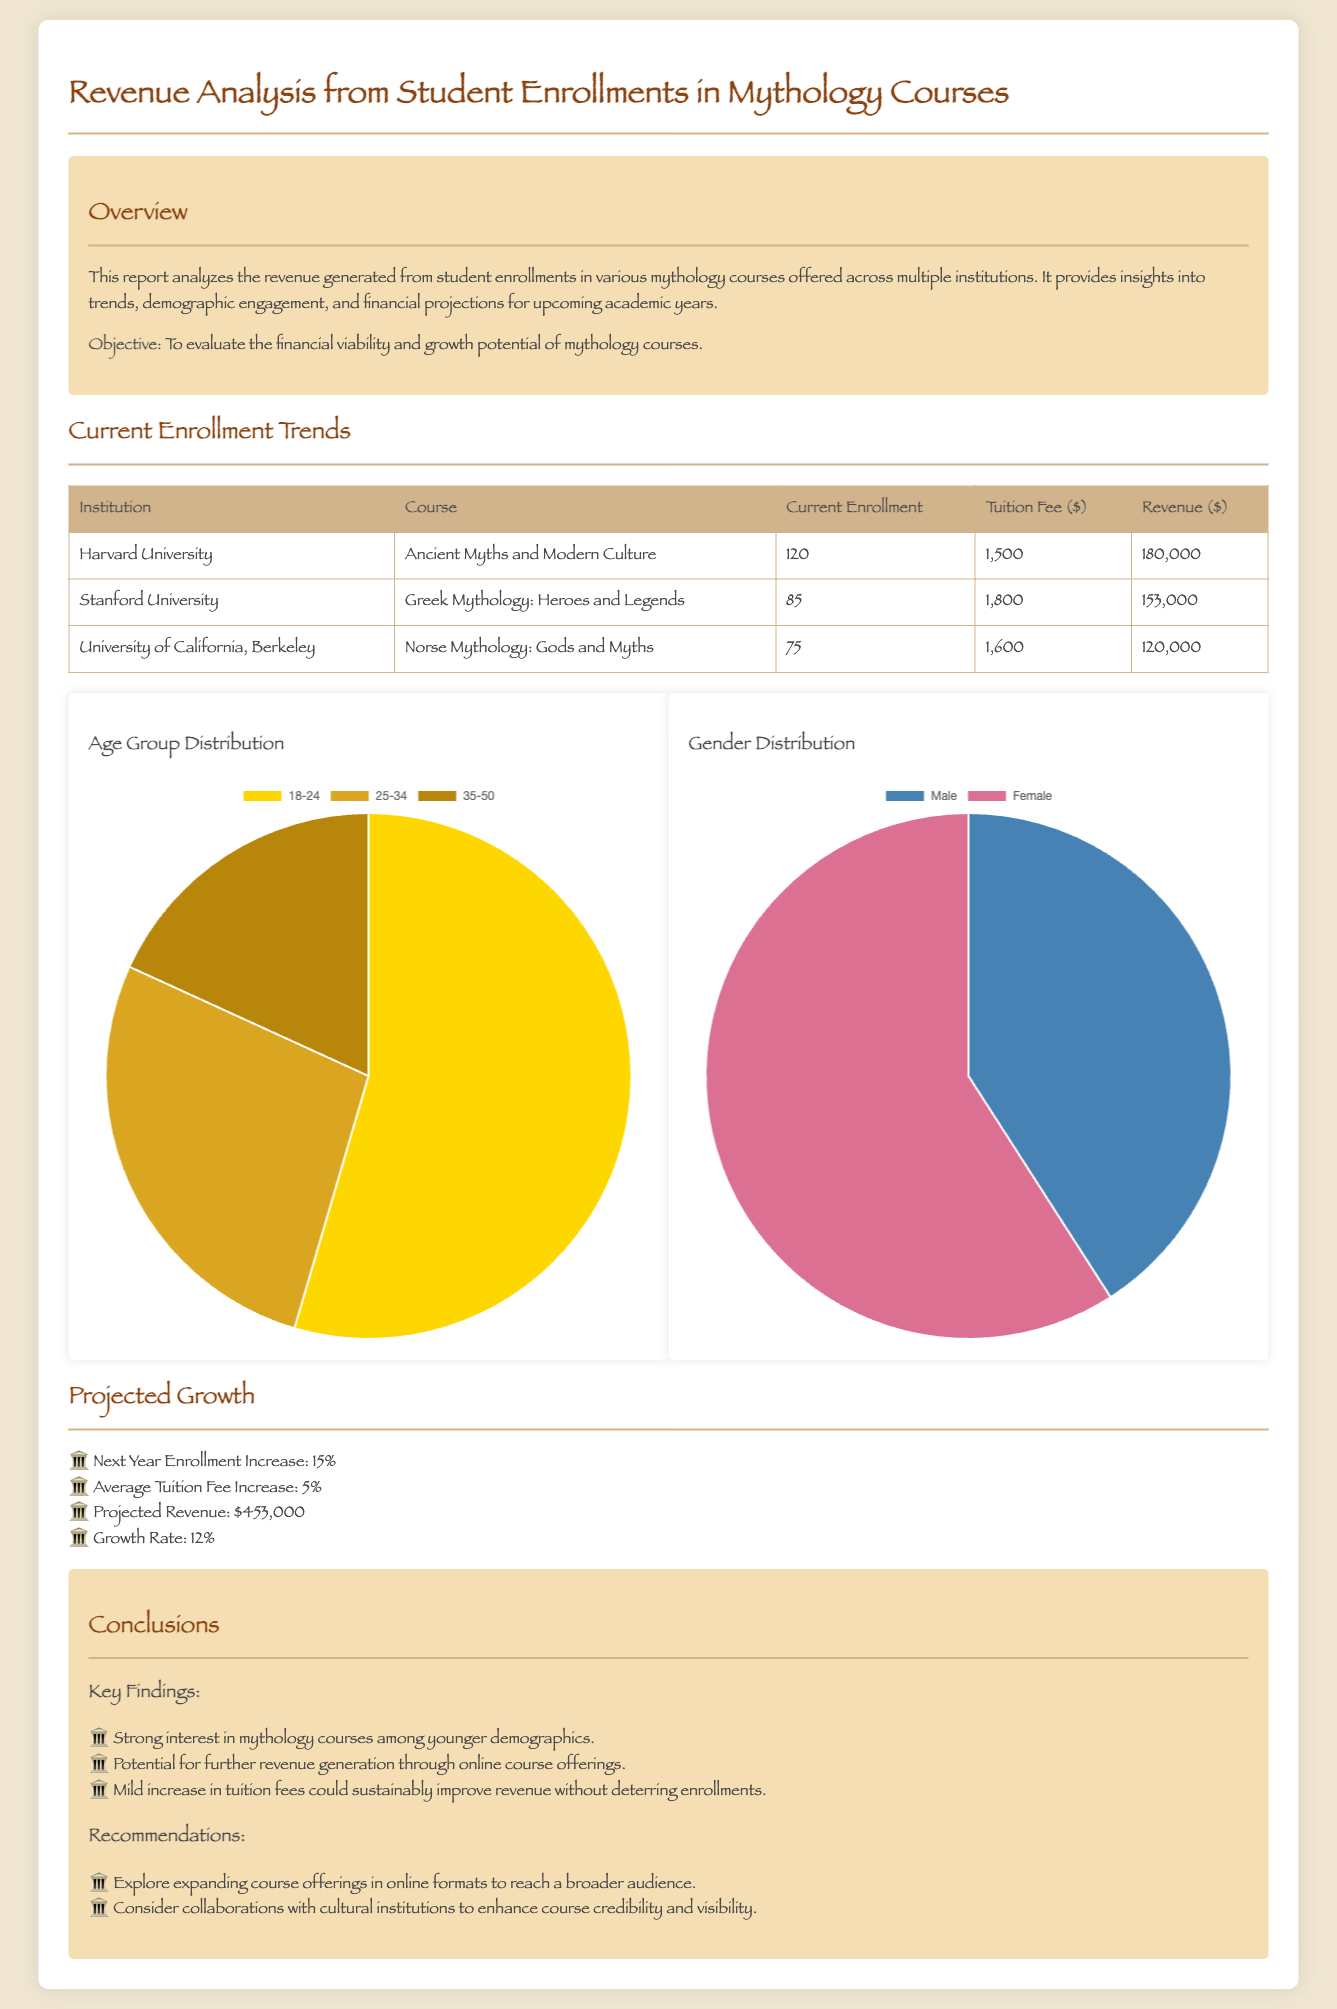What is the total revenue from Harvard University's course? The revenue from Harvard University's course is listed in the table as $180,000.
Answer: $180,000 What is the tuition fee for Stanford University's mythology course? The tuition fee for Stanford University's course is provided in the table as $1,800.
Answer: $1,800 What is the projected revenue for next year? The projected revenue for next year is stated in the document as $453,000.
Answer: $453,000 How much is the expected increase in enrollment for next year? The document mentions a 15% increase in enrollment for next year.
Answer: 15% Which age group has the highest distribution in the age group chart? The age group chart indicates that the 18-24 age group has the highest distribution at 60%.
Answer: 18-24 What is the growth rate projected for the upcoming academic years? The document specifies the growth rate as 12%.
Answer: 12% Who has a higher representation in the gender distribution chart? The gender distribution chart shows that females have a higher representation at 65%.
Answer: Females What course is offered by the University of California, Berkeley? The document lists the course "Norse Mythology: Gods and Myths" under this institution.
Answer: Norse Mythology: Gods and Myths What is a recommendation mentioned for enhancing course visibility? The report recommends considering collaborations with cultural institutions to enhance course visibility.
Answer: Collaborations with cultural institutions 